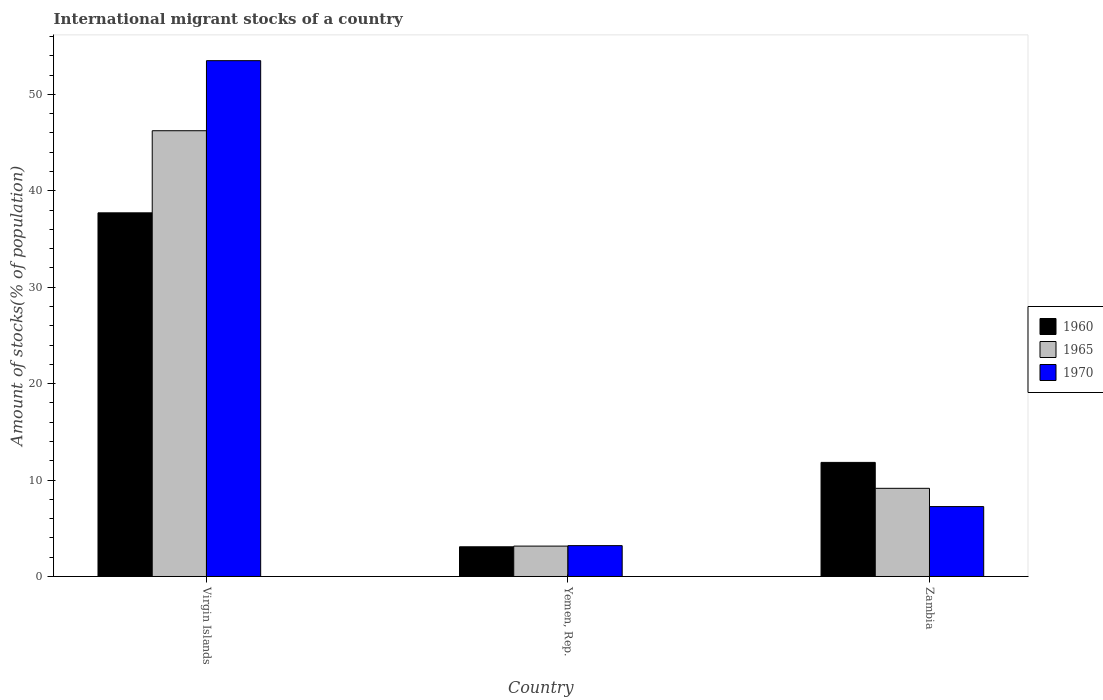How many different coloured bars are there?
Offer a very short reply. 3. How many groups of bars are there?
Your response must be concise. 3. Are the number of bars on each tick of the X-axis equal?
Provide a succinct answer. Yes. How many bars are there on the 2nd tick from the left?
Offer a very short reply. 3. What is the label of the 2nd group of bars from the left?
Ensure brevity in your answer.  Yemen, Rep. In how many cases, is the number of bars for a given country not equal to the number of legend labels?
Your answer should be very brief. 0. What is the amount of stocks in in 1960 in Yemen, Rep.?
Provide a succinct answer. 3.08. Across all countries, what is the maximum amount of stocks in in 1960?
Provide a succinct answer. 37.72. Across all countries, what is the minimum amount of stocks in in 1965?
Provide a short and direct response. 3.15. In which country was the amount of stocks in in 1970 maximum?
Give a very brief answer. Virgin Islands. In which country was the amount of stocks in in 1970 minimum?
Provide a short and direct response. Yemen, Rep. What is the total amount of stocks in in 1960 in the graph?
Offer a very short reply. 52.63. What is the difference between the amount of stocks in in 1970 in Virgin Islands and that in Zambia?
Offer a very short reply. 46.25. What is the difference between the amount of stocks in in 1965 in Yemen, Rep. and the amount of stocks in in 1960 in Virgin Islands?
Keep it short and to the point. -34.56. What is the average amount of stocks in in 1970 per country?
Provide a short and direct response. 21.32. What is the difference between the amount of stocks in of/in 1965 and amount of stocks in of/in 1960 in Yemen, Rep.?
Provide a short and direct response. 0.07. In how many countries, is the amount of stocks in in 1965 greater than 12 %?
Keep it short and to the point. 1. What is the ratio of the amount of stocks in in 1970 in Yemen, Rep. to that in Zambia?
Keep it short and to the point. 0.44. Is the difference between the amount of stocks in in 1965 in Virgin Islands and Zambia greater than the difference between the amount of stocks in in 1960 in Virgin Islands and Zambia?
Offer a terse response. Yes. What is the difference between the highest and the second highest amount of stocks in in 1970?
Offer a terse response. -50.3. What is the difference between the highest and the lowest amount of stocks in in 1960?
Your response must be concise. 34.64. In how many countries, is the amount of stocks in in 1965 greater than the average amount of stocks in in 1965 taken over all countries?
Offer a very short reply. 1. Is the sum of the amount of stocks in in 1970 in Yemen, Rep. and Zambia greater than the maximum amount of stocks in in 1960 across all countries?
Keep it short and to the point. No. What does the 1st bar from the left in Virgin Islands represents?
Offer a very short reply. 1960. What does the 3rd bar from the right in Yemen, Rep. represents?
Your answer should be compact. 1960. Is it the case that in every country, the sum of the amount of stocks in in 1965 and amount of stocks in in 1960 is greater than the amount of stocks in in 1970?
Provide a short and direct response. Yes. How many bars are there?
Ensure brevity in your answer.  9. Are all the bars in the graph horizontal?
Your answer should be compact. No. How many countries are there in the graph?
Keep it short and to the point. 3. Are the values on the major ticks of Y-axis written in scientific E-notation?
Keep it short and to the point. No. Where does the legend appear in the graph?
Your answer should be compact. Center right. How are the legend labels stacked?
Offer a terse response. Vertical. What is the title of the graph?
Offer a terse response. International migrant stocks of a country. Does "1990" appear as one of the legend labels in the graph?
Your answer should be very brief. No. What is the label or title of the X-axis?
Ensure brevity in your answer.  Country. What is the label or title of the Y-axis?
Make the answer very short. Amount of stocks(% of population). What is the Amount of stocks(% of population) of 1960 in Virgin Islands?
Give a very brief answer. 37.72. What is the Amount of stocks(% of population) of 1965 in Virgin Islands?
Keep it short and to the point. 46.23. What is the Amount of stocks(% of population) in 1970 in Virgin Islands?
Give a very brief answer. 53.5. What is the Amount of stocks(% of population) in 1960 in Yemen, Rep.?
Ensure brevity in your answer.  3.08. What is the Amount of stocks(% of population) in 1965 in Yemen, Rep.?
Keep it short and to the point. 3.15. What is the Amount of stocks(% of population) of 1970 in Yemen, Rep.?
Keep it short and to the point. 3.2. What is the Amount of stocks(% of population) in 1960 in Zambia?
Offer a terse response. 11.83. What is the Amount of stocks(% of population) in 1965 in Zambia?
Offer a very short reply. 9.14. What is the Amount of stocks(% of population) of 1970 in Zambia?
Offer a very short reply. 7.25. Across all countries, what is the maximum Amount of stocks(% of population) in 1960?
Provide a succinct answer. 37.72. Across all countries, what is the maximum Amount of stocks(% of population) in 1965?
Provide a succinct answer. 46.23. Across all countries, what is the maximum Amount of stocks(% of population) of 1970?
Offer a terse response. 53.5. Across all countries, what is the minimum Amount of stocks(% of population) of 1960?
Ensure brevity in your answer.  3.08. Across all countries, what is the minimum Amount of stocks(% of population) of 1965?
Give a very brief answer. 3.15. Across all countries, what is the minimum Amount of stocks(% of population) in 1970?
Make the answer very short. 3.2. What is the total Amount of stocks(% of population) of 1960 in the graph?
Your answer should be compact. 52.63. What is the total Amount of stocks(% of population) in 1965 in the graph?
Your answer should be compact. 58.53. What is the total Amount of stocks(% of population) in 1970 in the graph?
Offer a terse response. 63.95. What is the difference between the Amount of stocks(% of population) in 1960 in Virgin Islands and that in Yemen, Rep.?
Provide a short and direct response. 34.64. What is the difference between the Amount of stocks(% of population) of 1965 in Virgin Islands and that in Yemen, Rep.?
Give a very brief answer. 43.08. What is the difference between the Amount of stocks(% of population) in 1970 in Virgin Islands and that in Yemen, Rep.?
Ensure brevity in your answer.  50.3. What is the difference between the Amount of stocks(% of population) of 1960 in Virgin Islands and that in Zambia?
Your answer should be very brief. 25.88. What is the difference between the Amount of stocks(% of population) of 1965 in Virgin Islands and that in Zambia?
Offer a very short reply. 37.09. What is the difference between the Amount of stocks(% of population) of 1970 in Virgin Islands and that in Zambia?
Give a very brief answer. 46.25. What is the difference between the Amount of stocks(% of population) in 1960 in Yemen, Rep. and that in Zambia?
Provide a succinct answer. -8.75. What is the difference between the Amount of stocks(% of population) in 1965 in Yemen, Rep. and that in Zambia?
Provide a succinct answer. -5.99. What is the difference between the Amount of stocks(% of population) in 1970 in Yemen, Rep. and that in Zambia?
Offer a very short reply. -4.05. What is the difference between the Amount of stocks(% of population) of 1960 in Virgin Islands and the Amount of stocks(% of population) of 1965 in Yemen, Rep.?
Your answer should be very brief. 34.56. What is the difference between the Amount of stocks(% of population) of 1960 in Virgin Islands and the Amount of stocks(% of population) of 1970 in Yemen, Rep.?
Your answer should be very brief. 34.52. What is the difference between the Amount of stocks(% of population) of 1965 in Virgin Islands and the Amount of stocks(% of population) of 1970 in Yemen, Rep.?
Provide a succinct answer. 43.03. What is the difference between the Amount of stocks(% of population) of 1960 in Virgin Islands and the Amount of stocks(% of population) of 1965 in Zambia?
Ensure brevity in your answer.  28.57. What is the difference between the Amount of stocks(% of population) in 1960 in Virgin Islands and the Amount of stocks(% of population) in 1970 in Zambia?
Provide a succinct answer. 30.46. What is the difference between the Amount of stocks(% of population) of 1965 in Virgin Islands and the Amount of stocks(% of population) of 1970 in Zambia?
Offer a very short reply. 38.98. What is the difference between the Amount of stocks(% of population) of 1960 in Yemen, Rep. and the Amount of stocks(% of population) of 1965 in Zambia?
Your answer should be very brief. -6.06. What is the difference between the Amount of stocks(% of population) in 1960 in Yemen, Rep. and the Amount of stocks(% of population) in 1970 in Zambia?
Make the answer very short. -4.17. What is the difference between the Amount of stocks(% of population) of 1965 in Yemen, Rep. and the Amount of stocks(% of population) of 1970 in Zambia?
Keep it short and to the point. -4.1. What is the average Amount of stocks(% of population) in 1960 per country?
Provide a succinct answer. 17.54. What is the average Amount of stocks(% of population) of 1965 per country?
Ensure brevity in your answer.  19.51. What is the average Amount of stocks(% of population) in 1970 per country?
Ensure brevity in your answer.  21.32. What is the difference between the Amount of stocks(% of population) of 1960 and Amount of stocks(% of population) of 1965 in Virgin Islands?
Offer a terse response. -8.52. What is the difference between the Amount of stocks(% of population) in 1960 and Amount of stocks(% of population) in 1970 in Virgin Islands?
Your response must be concise. -15.78. What is the difference between the Amount of stocks(% of population) of 1965 and Amount of stocks(% of population) of 1970 in Virgin Islands?
Make the answer very short. -7.27. What is the difference between the Amount of stocks(% of population) of 1960 and Amount of stocks(% of population) of 1965 in Yemen, Rep.?
Your response must be concise. -0.07. What is the difference between the Amount of stocks(% of population) of 1960 and Amount of stocks(% of population) of 1970 in Yemen, Rep.?
Offer a terse response. -0.12. What is the difference between the Amount of stocks(% of population) in 1965 and Amount of stocks(% of population) in 1970 in Yemen, Rep.?
Offer a terse response. -0.05. What is the difference between the Amount of stocks(% of population) in 1960 and Amount of stocks(% of population) in 1965 in Zambia?
Make the answer very short. 2.69. What is the difference between the Amount of stocks(% of population) in 1960 and Amount of stocks(% of population) in 1970 in Zambia?
Give a very brief answer. 4.58. What is the difference between the Amount of stocks(% of population) in 1965 and Amount of stocks(% of population) in 1970 in Zambia?
Ensure brevity in your answer.  1.89. What is the ratio of the Amount of stocks(% of population) of 1960 in Virgin Islands to that in Yemen, Rep.?
Your answer should be very brief. 12.24. What is the ratio of the Amount of stocks(% of population) of 1965 in Virgin Islands to that in Yemen, Rep.?
Offer a terse response. 14.67. What is the ratio of the Amount of stocks(% of population) in 1970 in Virgin Islands to that in Yemen, Rep.?
Your response must be concise. 16.72. What is the ratio of the Amount of stocks(% of population) in 1960 in Virgin Islands to that in Zambia?
Your answer should be very brief. 3.19. What is the ratio of the Amount of stocks(% of population) in 1965 in Virgin Islands to that in Zambia?
Make the answer very short. 5.06. What is the ratio of the Amount of stocks(% of population) of 1970 in Virgin Islands to that in Zambia?
Ensure brevity in your answer.  7.38. What is the ratio of the Amount of stocks(% of population) of 1960 in Yemen, Rep. to that in Zambia?
Provide a succinct answer. 0.26. What is the ratio of the Amount of stocks(% of population) of 1965 in Yemen, Rep. to that in Zambia?
Your answer should be very brief. 0.34. What is the ratio of the Amount of stocks(% of population) in 1970 in Yemen, Rep. to that in Zambia?
Make the answer very short. 0.44. What is the difference between the highest and the second highest Amount of stocks(% of population) in 1960?
Provide a succinct answer. 25.88. What is the difference between the highest and the second highest Amount of stocks(% of population) in 1965?
Your answer should be compact. 37.09. What is the difference between the highest and the second highest Amount of stocks(% of population) in 1970?
Provide a succinct answer. 46.25. What is the difference between the highest and the lowest Amount of stocks(% of population) of 1960?
Offer a terse response. 34.64. What is the difference between the highest and the lowest Amount of stocks(% of population) of 1965?
Offer a very short reply. 43.08. What is the difference between the highest and the lowest Amount of stocks(% of population) of 1970?
Offer a very short reply. 50.3. 